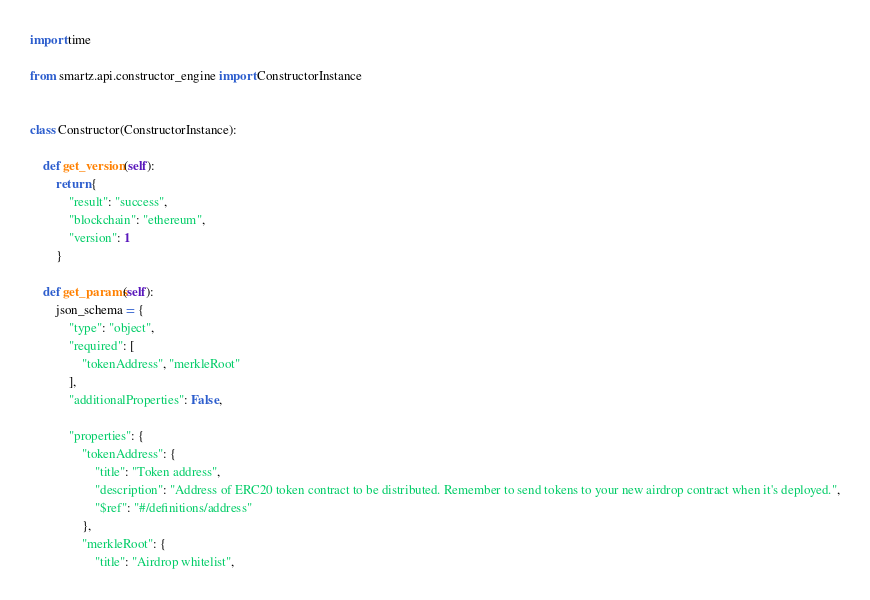<code> <loc_0><loc_0><loc_500><loc_500><_Python_>import time

from smartz.api.constructor_engine import ConstructorInstance


class Constructor(ConstructorInstance):

    def get_version(self):
        return {
            "result": "success",
            "blockchain": "ethereum",
            "version": 1
        }

    def get_params(self):
        json_schema = {
            "type": "object",
            "required": [
                "tokenAddress", "merkleRoot"
            ],
            "additionalProperties": False,

            "properties": {
                "tokenAddress": {
                    "title": "Token address",
                    "description": "Address of ERC20 token contract to be distributed. Remember to send tokens to your new airdrop contract when it's deployed.",
                    "$ref": "#/definitions/address"
                },
                "merkleRoot": {
                    "title": "Airdrop whitelist",</code> 